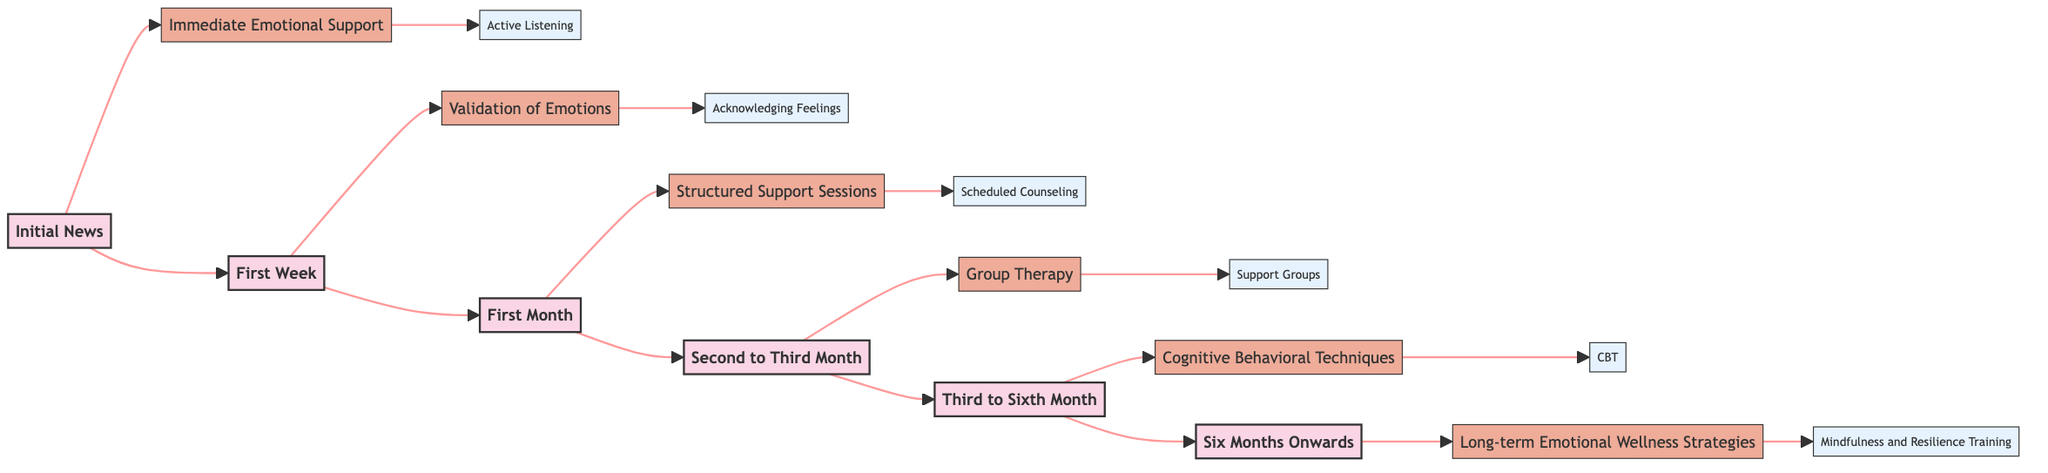What technique is associated with the initial news? The initial news stage is linked to the technique of immediate emotional support, which is specified on the diagram next to the stage.
Answer: Immediate Emotional Support How many stages are represented in the diagram? By counting the distinct stages listed in the flowchart, five stages are identified: Initial News, First Week, First Month, Second to Third Month, Third to Sixth Month, and Six Months Onwards.
Answer: Six What is the method used for the technique in the first week? In the flowchart, the first week is associated with the technique of validation of emotions, which has the method of acknowledging feelings described adjacent to it.
Answer: Acknowledging Feelings Which stage follows the first month? The flow of the diagram shows that after the first month, the next stage is the second to third month, as indicated by the arrows connecting the stages.
Answer: Second to Third Month What type of support is described for the period of three to six months? The diagram specifies that during the period of three to six months, cognitive behavioral techniques are applied, as denoted in that stage of the flowchart.
Answer: Cognitive Behavioral Techniques What description is provided for structured support sessions? Referring to the specific details listed under structured support sessions, the description states that it involves regularly scheduled one-on-one counseling sessions.
Answer: Regularly scheduled one-on-one counseling sessions What is the focus of long-term emotional wellness strategies? The last stage emphasizes ongoing practices to support emotional well-being, as specifically indicated under long-term emotional wellness strategies next to mindfulness and resilience training.
Answer: Ongoing practices to support emotional well-being What does the group therapy technique involve? The diagram outlines that the technique of group therapy consists of facilitated group sessions with others who have experienced similar losses based on the details provided for that stage.
Answer: Facilitated group sessions with others who have experienced similar losses What is the earliest application of active listening? The flowchart indicates that active listening is applied during the early days after the loss is discovered, as specified under the immediate emotional support technique in the initial news stage.
Answer: Early days after the loss is discovered 